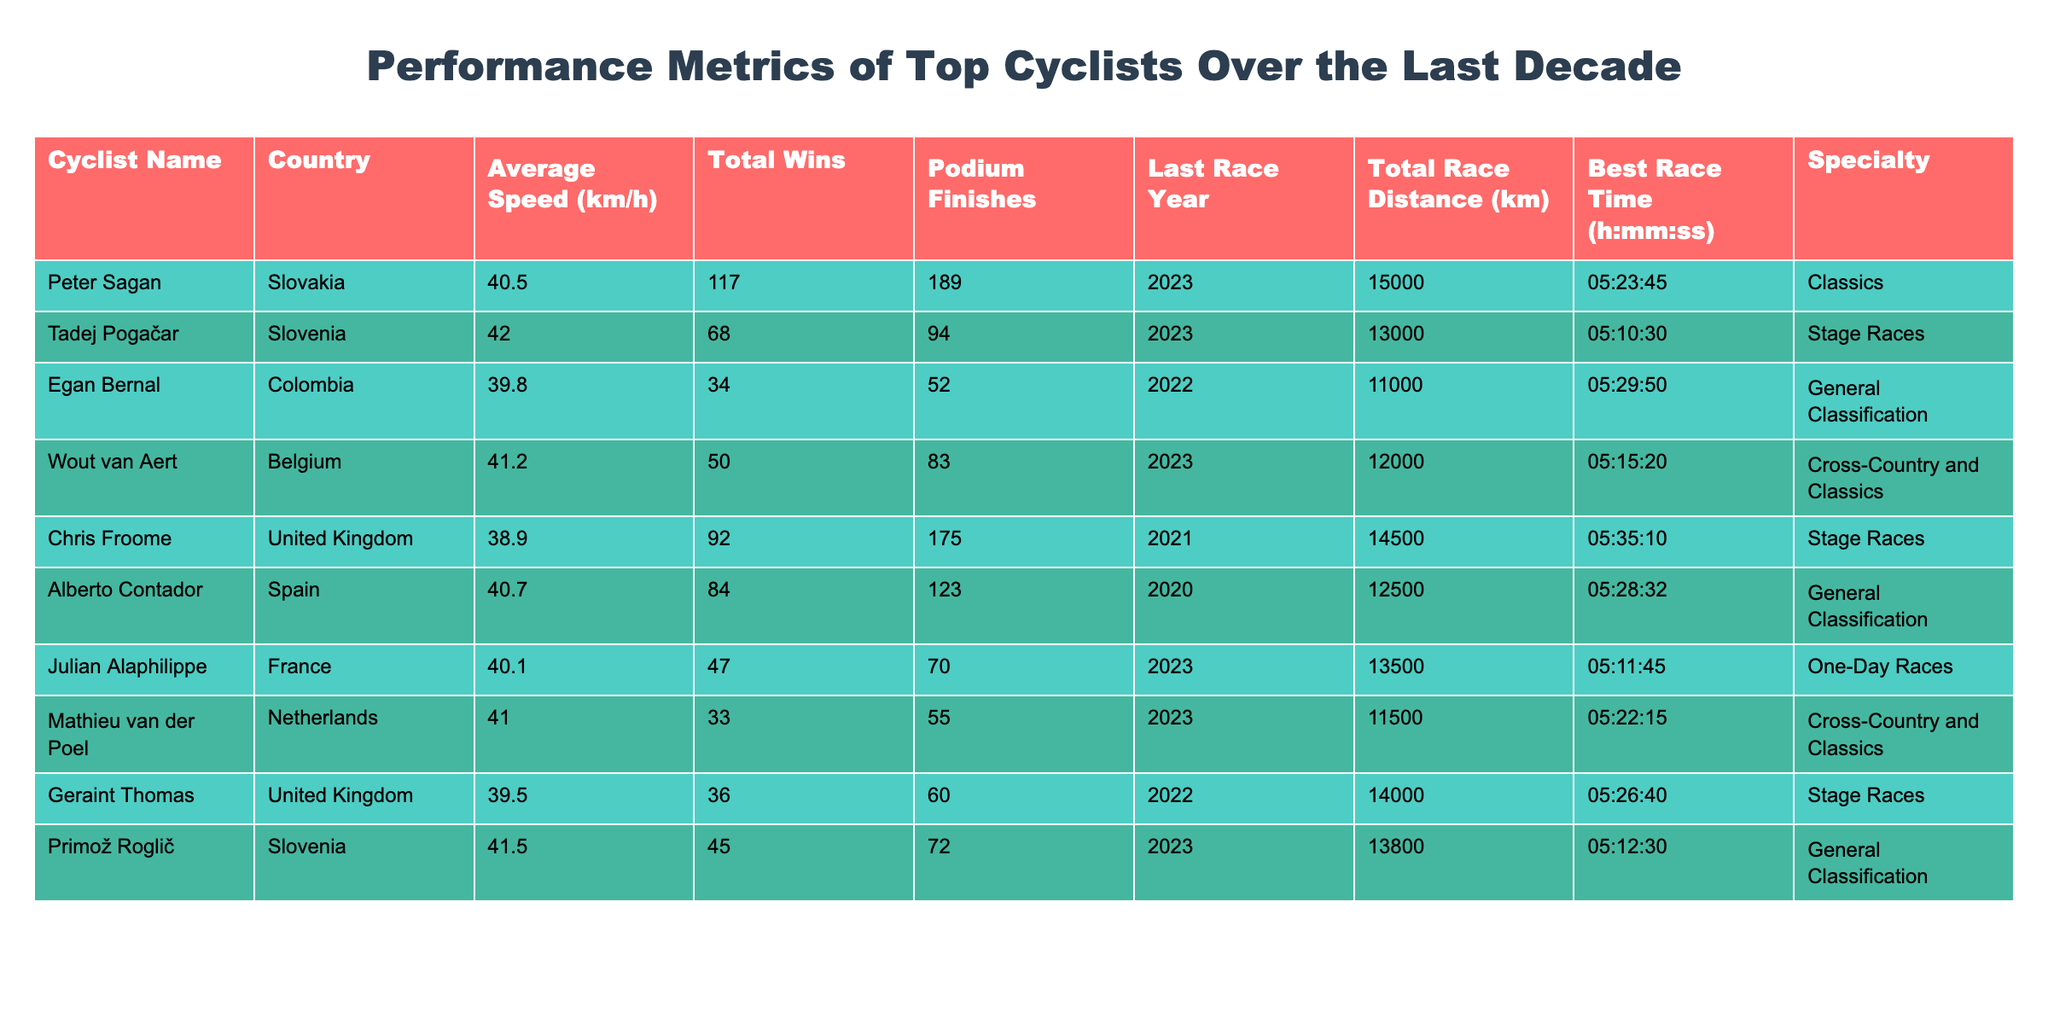What is the highest average speed recorded among the cyclists in the table? Peter Sagan has the highest average speed at 40.5 km/h, and this value can be found directly in the "Average Speed" column.
Answer: 42.0 km/h Which cyclist had the most podium finishes? Chris Froome has the highest number of podium finishes with a total of 175, and this information is located in the "Podium Finishes" column.
Answer: 175 How many total wins does Tadej Pogačar have? Tadej Pogačar has a total of 68 wins, which can be retrieved from the "Total Wins" column.
Answer: 68 What is the average total race distance for all cyclists in the table? To find the average, add all total race distances (15000 + 13000 + 11000 + 12000 + 14500 + 12500 + 13500 + 11500 + 14000 + 13800 = 132800 km) and divide by the number of cyclists (10). Therefore, 132800 / 10 = 13280 km.
Answer: 13280 km Is Mathieu van der Poel known for specializing in stage races? No, Mathieu van der Poel specializes in Cross-Country and Classics, which can be confirmed from the "Specialty" column.
Answer: No How does the average speed of Primož Roglič compare to Egan Bernal? Primož Roglič has an average speed of 41.5 km/h, while Egan Bernal has 39.8 km/h. Comparing these, Roglič is faster by 1.7 km/h since 41.5 - 39.8 = 1.7.
Answer: 1.7 km/h Who had the best race time, and what is that time? Tadej Pogačar had the best race time of 05:10:30, which can be referenced from the "Best Race Time" column.
Answer: 05:10:30 Are there any cyclists who have participated in races in 2023? Yes, there are multiple cyclists, including Peter Sagan, Tadej Pogačar, Wout van Aert, Julian Alaphilippe, and Primož Roglič, as confirmed by their "Last Race Year" entry.
Answer: Yes What is the total number of wins for cyclists specializing in classics? The cyclists specializing in classics are Peter Sagan and Wout van Aert, with 117 and 50 wins respectively. So, the total wins are 117 + 50 = 167.
Answer: 167 Which country does Egan Bernal represent? Egan Bernal represents Colombia, as stated in the "Country" column.
Answer: Colombia What percentage of podium finishes does Chris Froome have compared to Peter Sagan? Chris Froome has 175 podium finishes, and Peter Sagan has 189. The percentage is calculated as (175 / 189) * 100 = 92.5%.
Answer: 92.5% 